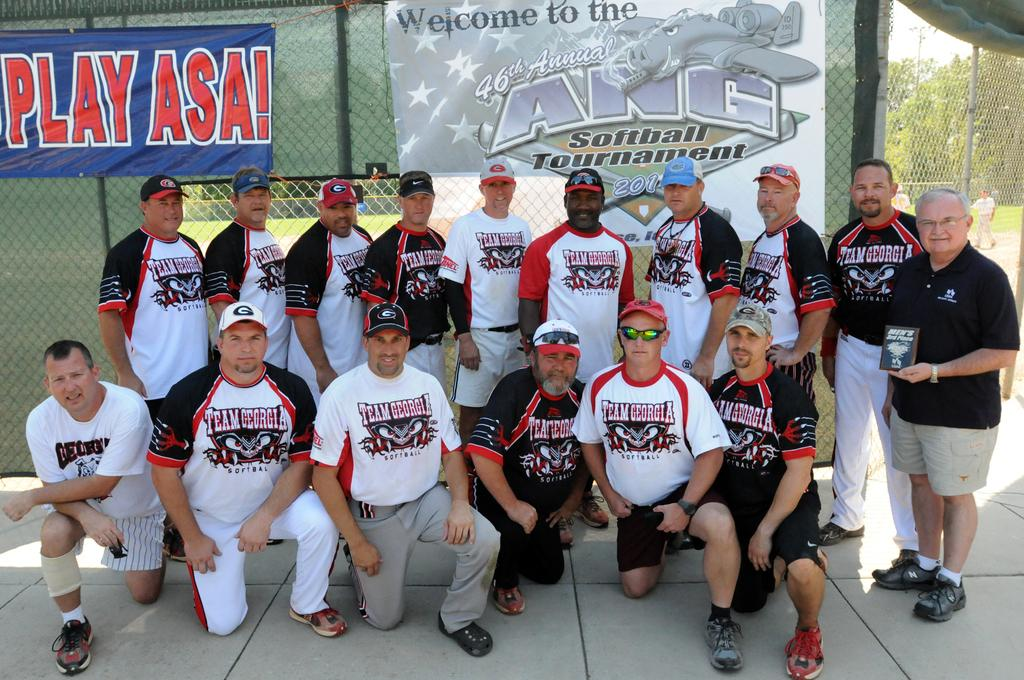Provide a one-sentence caption for the provided image. A softball team takes a picture in front of the ANG tournament banner. 